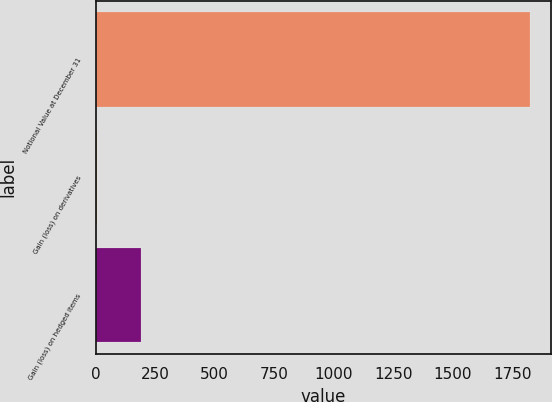Convert chart. <chart><loc_0><loc_0><loc_500><loc_500><bar_chart><fcel>Notional Value at December 31<fcel>Gain (loss) on derivatives<fcel>Gain (loss) on hedged items<nl><fcel>1823<fcel>7<fcel>188.6<nl></chart> 